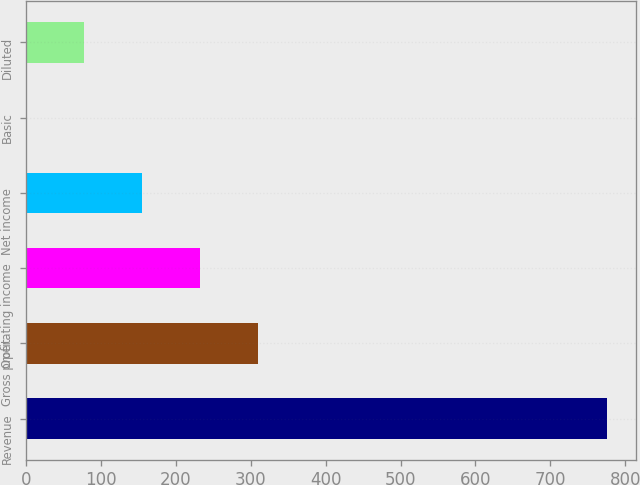<chart> <loc_0><loc_0><loc_500><loc_500><bar_chart><fcel>Revenue<fcel>Gross profit<fcel>Operating income<fcel>Net income<fcel>Basic<fcel>Diluted<nl><fcel>775<fcel>310.26<fcel>232.81<fcel>155.36<fcel>0.46<fcel>77.91<nl></chart> 